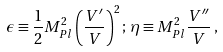<formula> <loc_0><loc_0><loc_500><loc_500>\epsilon \equiv \frac { 1 } { 2 } M _ { P l } ^ { 2 } \left ( \frac { V ^ { \prime } } { V } \right ) ^ { 2 } ; \, \eta \equiv M _ { P l } ^ { 2 } { \frac { V ^ { \prime \prime } } { V } } \, ,</formula> 